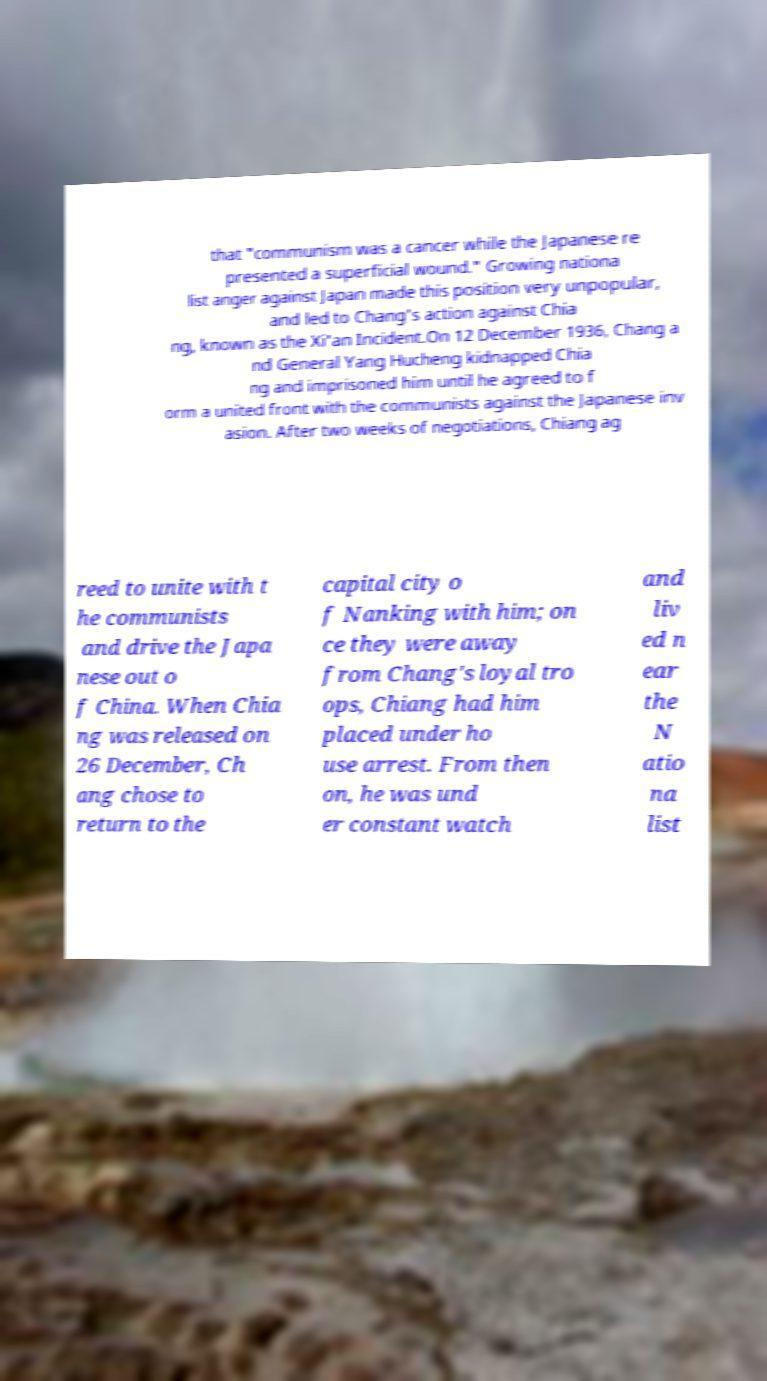There's text embedded in this image that I need extracted. Can you transcribe it verbatim? that "communism was a cancer while the Japanese re presented a superficial wound." Growing nationa list anger against Japan made this position very unpopular, and led to Chang's action against Chia ng, known as the Xi'an Incident.On 12 December 1936, Chang a nd General Yang Hucheng kidnapped Chia ng and imprisoned him until he agreed to f orm a united front with the communists against the Japanese inv asion. After two weeks of negotiations, Chiang ag reed to unite with t he communists and drive the Japa nese out o f China. When Chia ng was released on 26 December, Ch ang chose to return to the capital city o f Nanking with him; on ce they were away from Chang's loyal tro ops, Chiang had him placed under ho use arrest. From then on, he was und er constant watch and liv ed n ear the N atio na list 